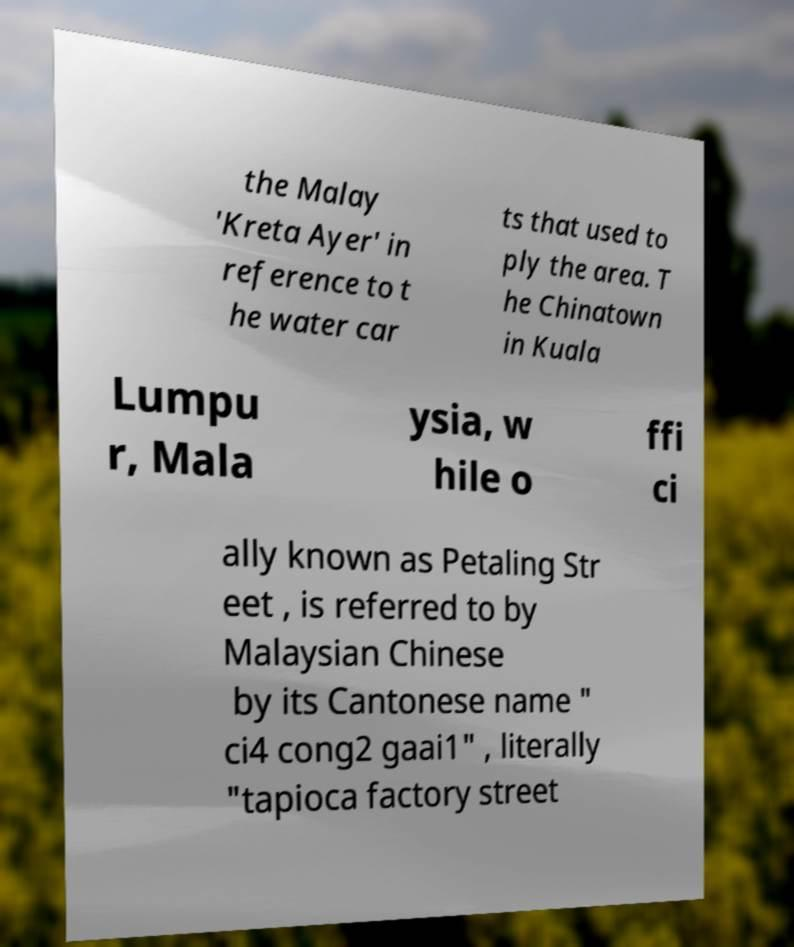I need the written content from this picture converted into text. Can you do that? the Malay 'Kreta Ayer' in reference to t he water car ts that used to ply the area. T he Chinatown in Kuala Lumpu r, Mala ysia, w hile o ffi ci ally known as Petaling Str eet , is referred to by Malaysian Chinese by its Cantonese name " ci4 cong2 gaai1" , literally "tapioca factory street 